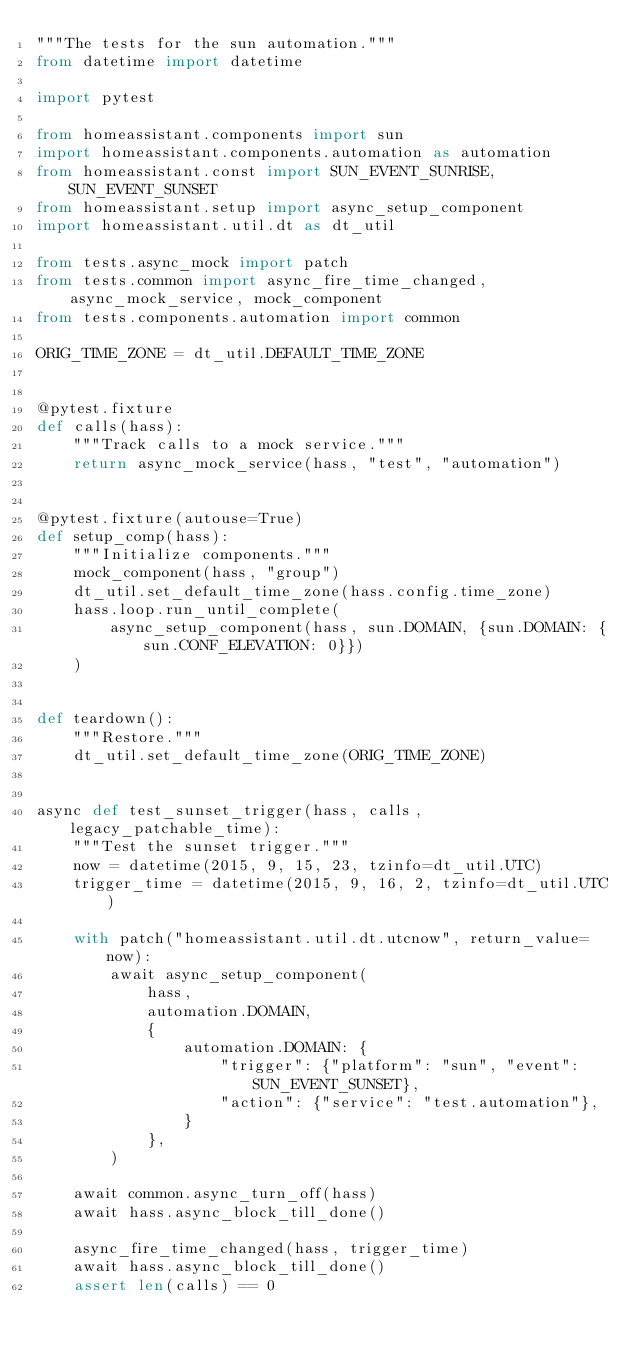Convert code to text. <code><loc_0><loc_0><loc_500><loc_500><_Python_>"""The tests for the sun automation."""
from datetime import datetime

import pytest

from homeassistant.components import sun
import homeassistant.components.automation as automation
from homeassistant.const import SUN_EVENT_SUNRISE, SUN_EVENT_SUNSET
from homeassistant.setup import async_setup_component
import homeassistant.util.dt as dt_util

from tests.async_mock import patch
from tests.common import async_fire_time_changed, async_mock_service, mock_component
from tests.components.automation import common

ORIG_TIME_ZONE = dt_util.DEFAULT_TIME_ZONE


@pytest.fixture
def calls(hass):
    """Track calls to a mock service."""
    return async_mock_service(hass, "test", "automation")


@pytest.fixture(autouse=True)
def setup_comp(hass):
    """Initialize components."""
    mock_component(hass, "group")
    dt_util.set_default_time_zone(hass.config.time_zone)
    hass.loop.run_until_complete(
        async_setup_component(hass, sun.DOMAIN, {sun.DOMAIN: {sun.CONF_ELEVATION: 0}})
    )


def teardown():
    """Restore."""
    dt_util.set_default_time_zone(ORIG_TIME_ZONE)


async def test_sunset_trigger(hass, calls, legacy_patchable_time):
    """Test the sunset trigger."""
    now = datetime(2015, 9, 15, 23, tzinfo=dt_util.UTC)
    trigger_time = datetime(2015, 9, 16, 2, tzinfo=dt_util.UTC)

    with patch("homeassistant.util.dt.utcnow", return_value=now):
        await async_setup_component(
            hass,
            automation.DOMAIN,
            {
                automation.DOMAIN: {
                    "trigger": {"platform": "sun", "event": SUN_EVENT_SUNSET},
                    "action": {"service": "test.automation"},
                }
            },
        )

    await common.async_turn_off(hass)
    await hass.async_block_till_done()

    async_fire_time_changed(hass, trigger_time)
    await hass.async_block_till_done()
    assert len(calls) == 0
</code> 